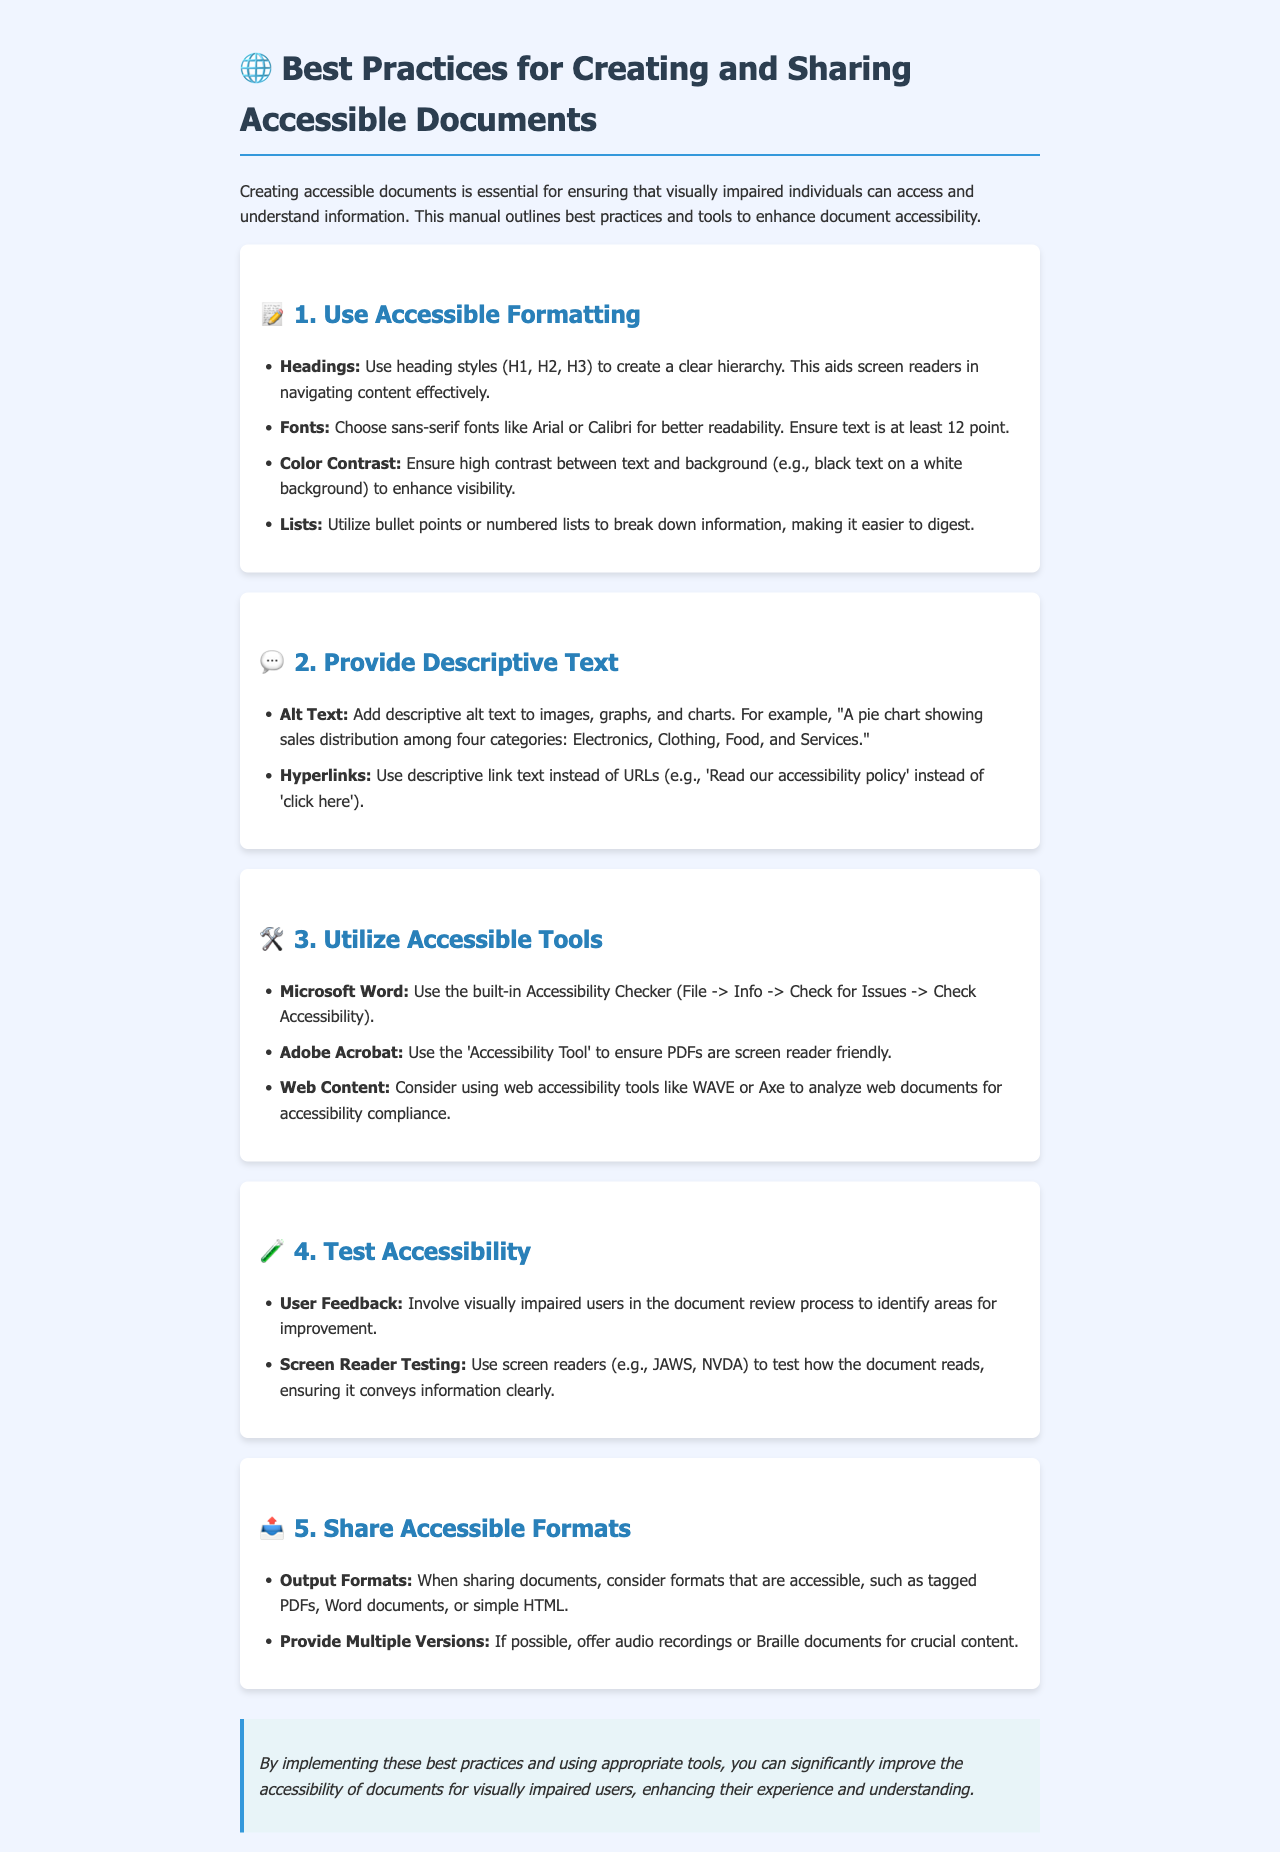What are some recommended fonts for better readability? The document suggests choosing sans-serif fonts like Arial or Calibri for better readability.
Answer: Arial or Calibri What should be ensured for color contrast? The document states that high contrast should be ensured between text and background to enhance visibility.
Answer: High contrast What is the first step in creating accessible documents? The manual outlines that using accessible formatting, specifically headings, is the first best practice.
Answer: Use accessible formatting Which tool can be used to test for document accessibility in Microsoft Word? The Accessibility Checker in Microsoft Word is mentioned as a tool for checking accessibility compliance.
Answer: Accessibility Checker What type of text should be added to images for better accessibility? The document indicates that descriptive alt text should be added to images, graphs, and charts.
Answer: Descriptive alt text How can feedback be gathered for improving document accessibility? Involvement of visually impaired users in the document review process is recommended for gathering feedback.
Answer: User feedback What formats are recommended for sharing accessible documents? The document suggests sharing tagged PDFs, Word documents, or simple HTML as accessible formats.
Answer: Tagged PDFs, Word documents, simple HTML What is one way to enhance document comprehension for visually impaired users? Providing multiple versions like audio recordings or Braille documents is recommended for crucial content.
Answer: Multiple versions Which screen reader is mentioned for testing document accessibility? The manual mentions JAWS and NVDA as screen readers that can be used for testing.
Answer: JAWS or NVDA 